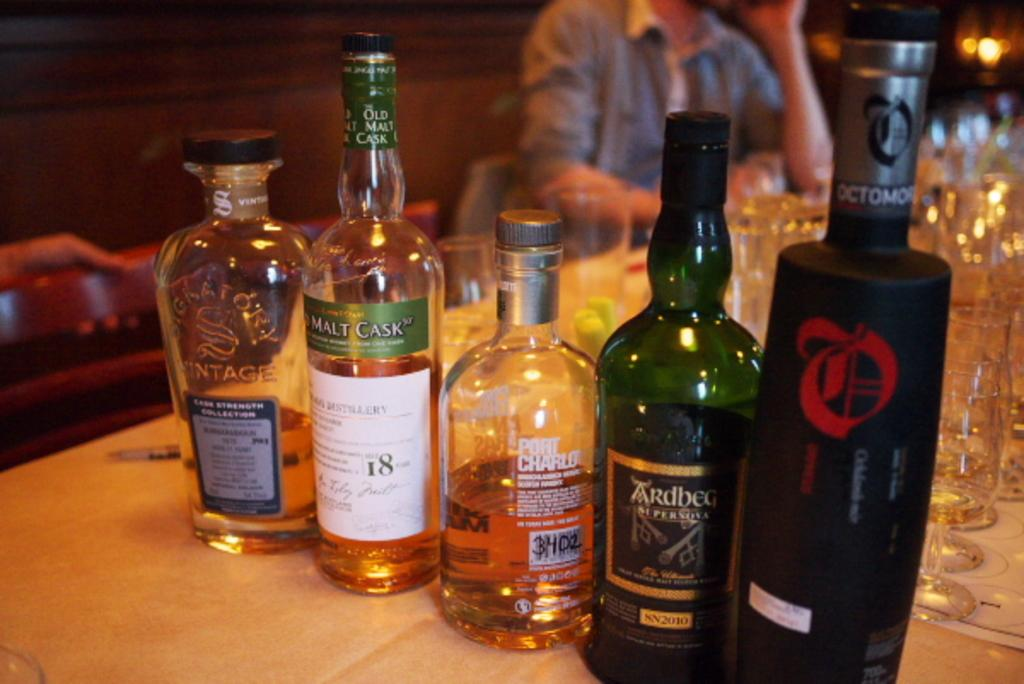<image>
Summarize the visual content of the image. five different bottles on the table, one labelled Ardbeg. 